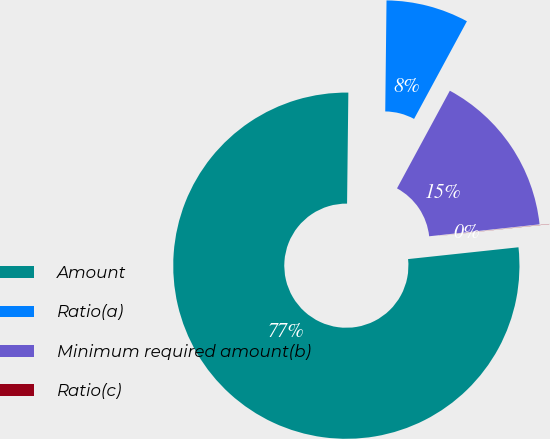Convert chart to OTSL. <chart><loc_0><loc_0><loc_500><loc_500><pie_chart><fcel>Amount<fcel>Ratio(a)<fcel>Minimum required amount(b)<fcel>Ratio(c)<nl><fcel>76.88%<fcel>7.71%<fcel>15.39%<fcel>0.02%<nl></chart> 